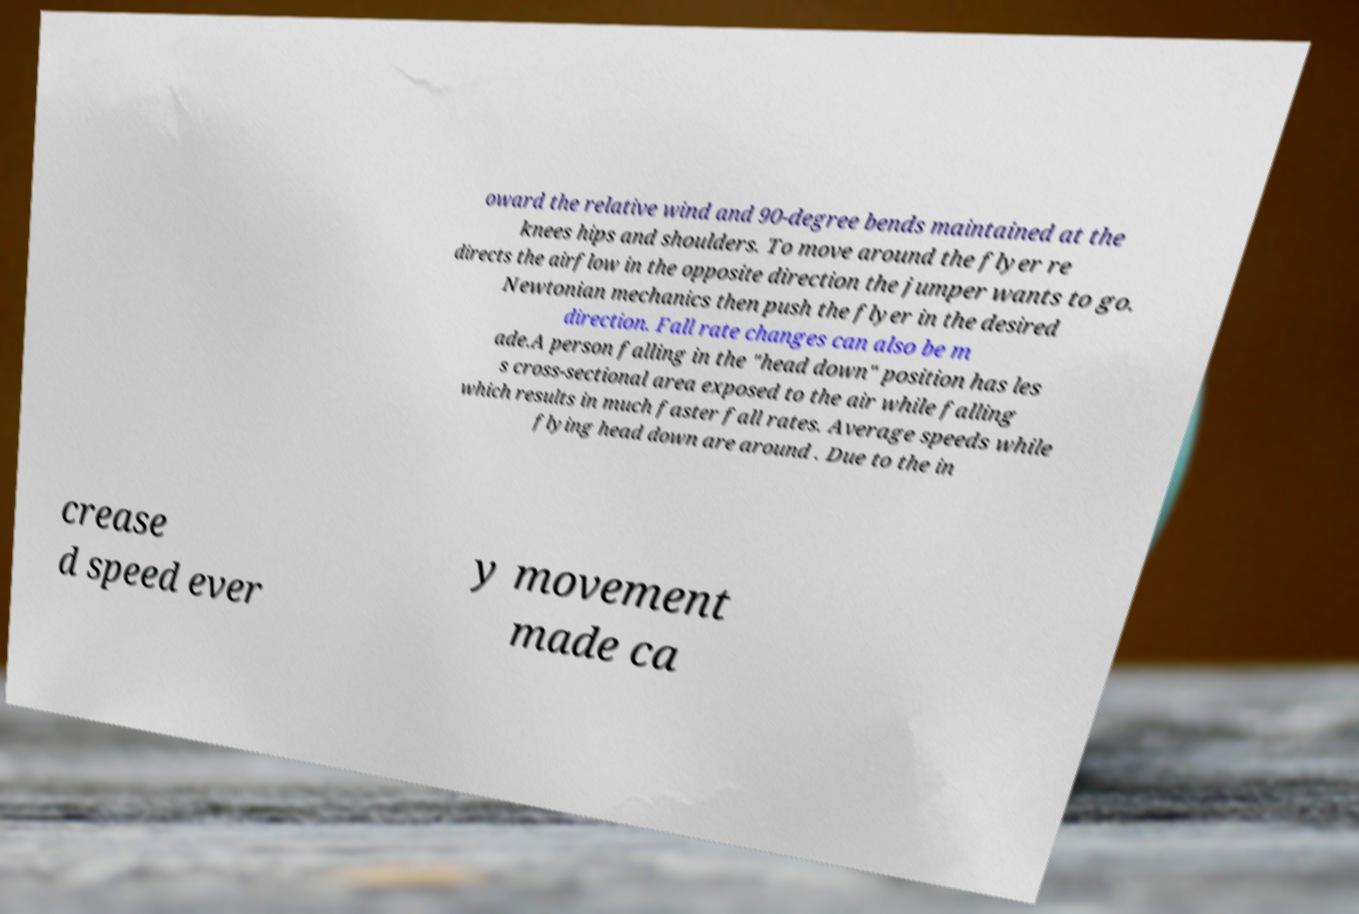What messages or text are displayed in this image? I need them in a readable, typed format. oward the relative wind and 90-degree bends maintained at the knees hips and shoulders. To move around the flyer re directs the airflow in the opposite direction the jumper wants to go. Newtonian mechanics then push the flyer in the desired direction. Fall rate changes can also be m ade.A person falling in the "head down" position has les s cross-sectional area exposed to the air while falling which results in much faster fall rates. Average speeds while flying head down are around . Due to the in crease d speed ever y movement made ca 